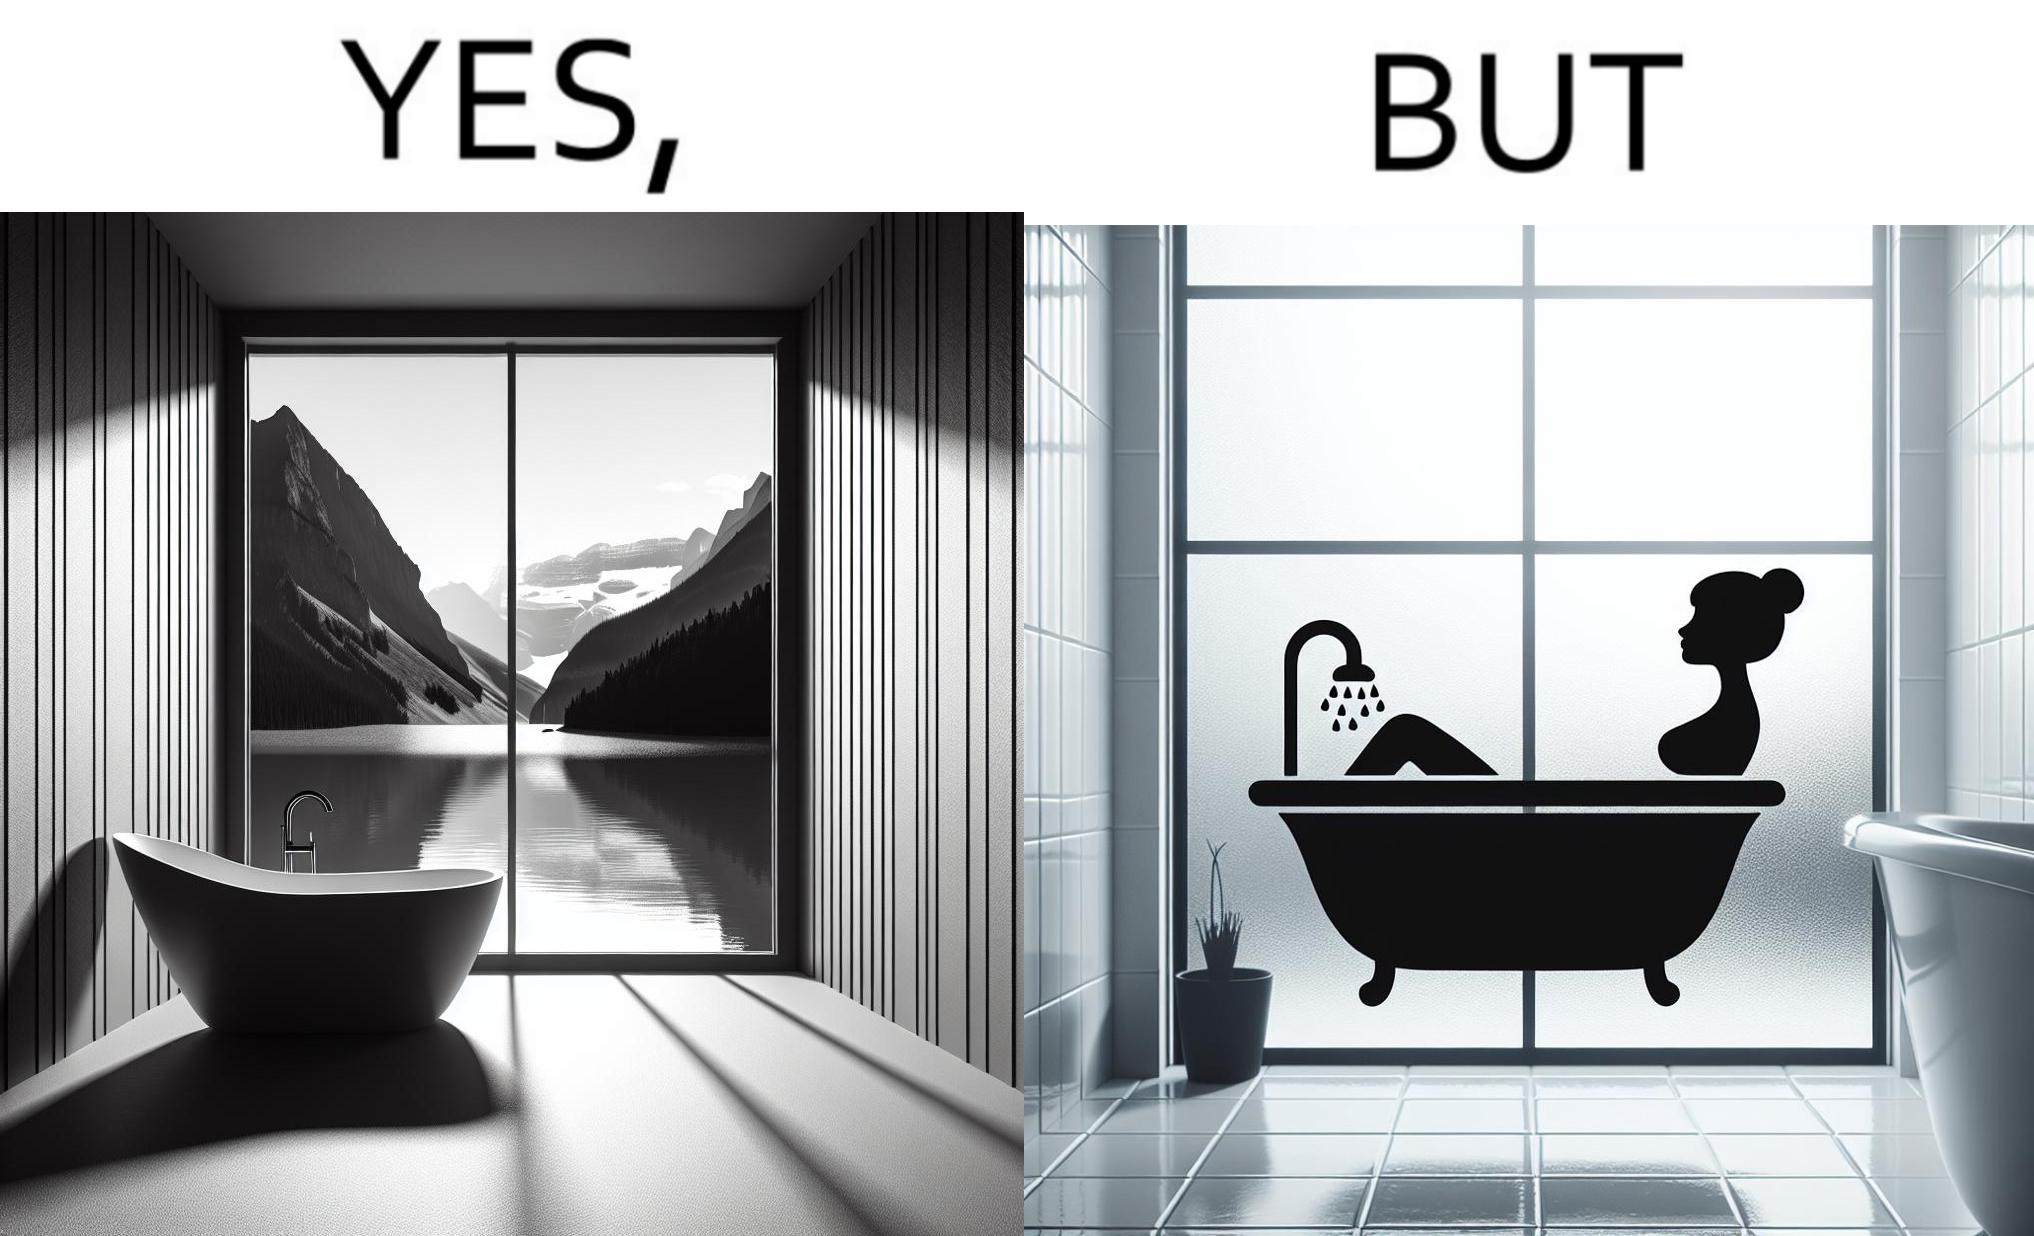Is there satirical content in this image? Yes, this image is satirical. 